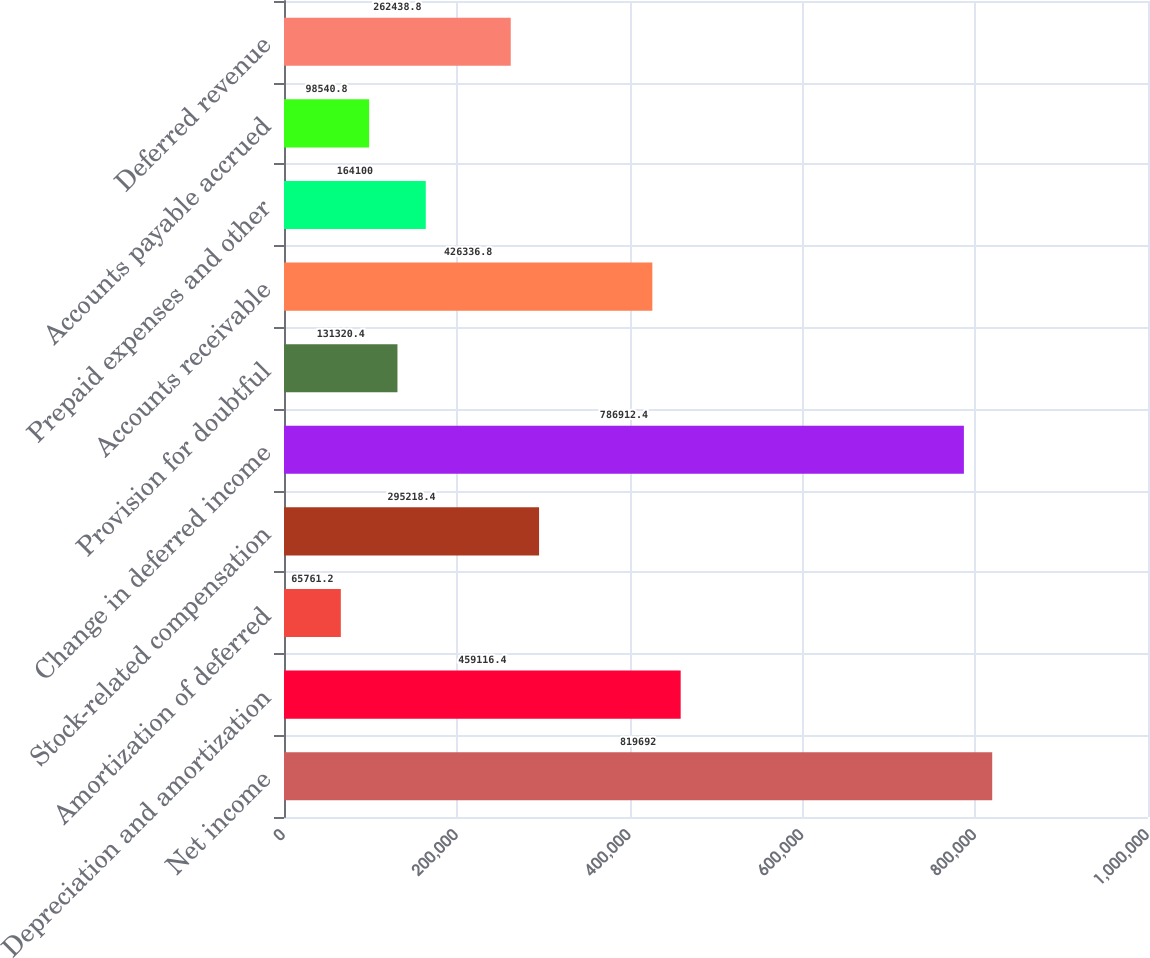<chart> <loc_0><loc_0><loc_500><loc_500><bar_chart><fcel>Net income<fcel>Depreciation and amortization<fcel>Amortization of deferred<fcel>Stock-related compensation<fcel>Change in deferred income<fcel>Provision for doubtful<fcel>Accounts receivable<fcel>Prepaid expenses and other<fcel>Accounts payable accrued<fcel>Deferred revenue<nl><fcel>819692<fcel>459116<fcel>65761.2<fcel>295218<fcel>786912<fcel>131320<fcel>426337<fcel>164100<fcel>98540.8<fcel>262439<nl></chart> 